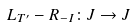Convert formula to latex. <formula><loc_0><loc_0><loc_500><loc_500>L _ { T ^ { \prime } } - R _ { - I } \colon J \to J</formula> 